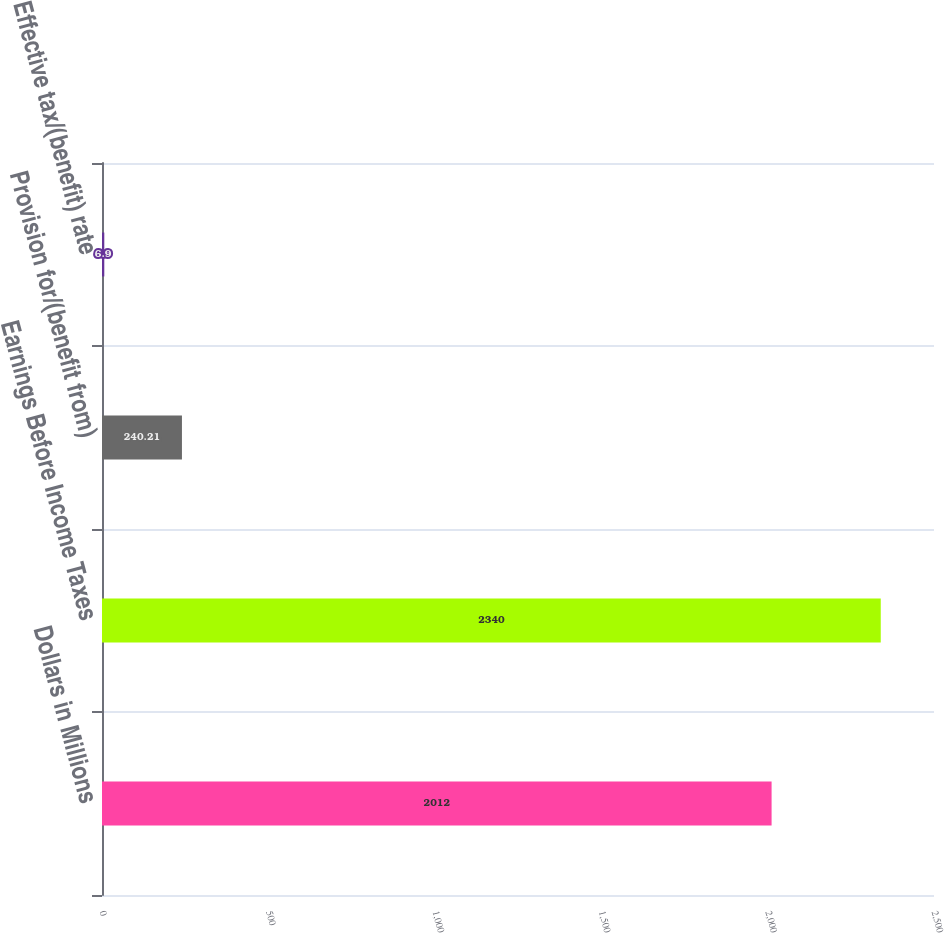<chart> <loc_0><loc_0><loc_500><loc_500><bar_chart><fcel>Dollars in Millions<fcel>Earnings Before Income Taxes<fcel>Provision for/(benefit from)<fcel>Effective tax/(benefit) rate<nl><fcel>2012<fcel>2340<fcel>240.21<fcel>6.9<nl></chart> 